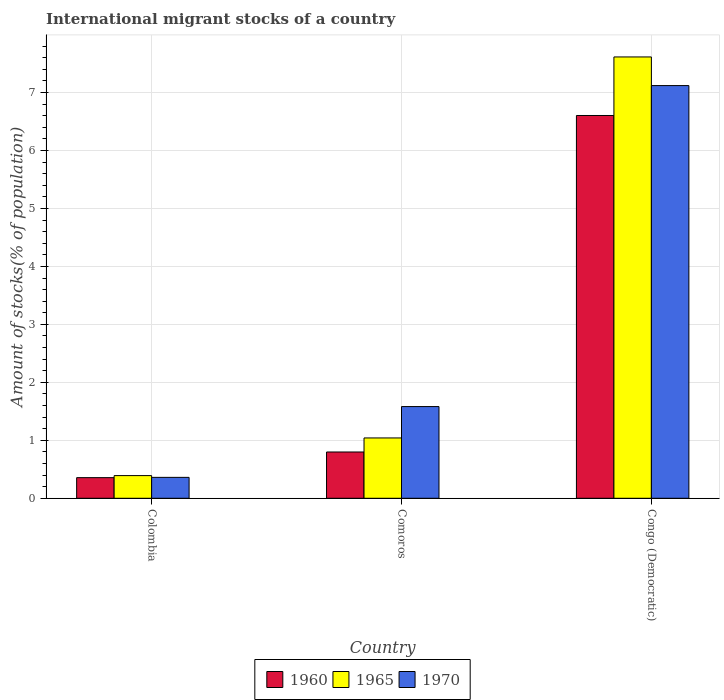Are the number of bars on each tick of the X-axis equal?
Ensure brevity in your answer.  Yes. How many bars are there on the 3rd tick from the left?
Provide a succinct answer. 3. What is the label of the 2nd group of bars from the left?
Make the answer very short. Comoros. What is the amount of stocks in in 1965 in Congo (Democratic)?
Ensure brevity in your answer.  7.61. Across all countries, what is the maximum amount of stocks in in 1965?
Your answer should be compact. 7.61. Across all countries, what is the minimum amount of stocks in in 1970?
Give a very brief answer. 0.36. In which country was the amount of stocks in in 1960 maximum?
Offer a terse response. Congo (Democratic). In which country was the amount of stocks in in 1960 minimum?
Offer a terse response. Colombia. What is the total amount of stocks in in 1970 in the graph?
Provide a succinct answer. 9.06. What is the difference between the amount of stocks in in 1960 in Colombia and that in Comoros?
Your answer should be very brief. -0.44. What is the difference between the amount of stocks in in 1965 in Colombia and the amount of stocks in in 1960 in Congo (Democratic)?
Offer a terse response. -6.21. What is the average amount of stocks in in 1960 per country?
Your answer should be very brief. 2.59. What is the difference between the amount of stocks in of/in 1965 and amount of stocks in of/in 1960 in Comoros?
Provide a short and direct response. 0.24. In how many countries, is the amount of stocks in in 1960 greater than 2.8 %?
Make the answer very short. 1. What is the ratio of the amount of stocks in in 1965 in Colombia to that in Comoros?
Offer a terse response. 0.38. Is the difference between the amount of stocks in in 1965 in Colombia and Congo (Democratic) greater than the difference between the amount of stocks in in 1960 in Colombia and Congo (Democratic)?
Ensure brevity in your answer.  No. What is the difference between the highest and the second highest amount of stocks in in 1970?
Make the answer very short. -1.22. What is the difference between the highest and the lowest amount of stocks in in 1965?
Keep it short and to the point. 7.22. Is the sum of the amount of stocks in in 1965 in Colombia and Comoros greater than the maximum amount of stocks in in 1960 across all countries?
Provide a short and direct response. No. What does the 2nd bar from the right in Colombia represents?
Offer a very short reply. 1965. How many countries are there in the graph?
Provide a succinct answer. 3. Does the graph contain any zero values?
Give a very brief answer. No. Does the graph contain grids?
Your answer should be compact. Yes. What is the title of the graph?
Ensure brevity in your answer.  International migrant stocks of a country. What is the label or title of the Y-axis?
Your response must be concise. Amount of stocks(% of population). What is the Amount of stocks(% of population) in 1960 in Colombia?
Give a very brief answer. 0.36. What is the Amount of stocks(% of population) in 1965 in Colombia?
Offer a terse response. 0.39. What is the Amount of stocks(% of population) of 1970 in Colombia?
Your answer should be very brief. 0.36. What is the Amount of stocks(% of population) in 1960 in Comoros?
Give a very brief answer. 0.8. What is the Amount of stocks(% of population) of 1965 in Comoros?
Offer a terse response. 1.04. What is the Amount of stocks(% of population) of 1970 in Comoros?
Ensure brevity in your answer.  1.58. What is the Amount of stocks(% of population) in 1960 in Congo (Democratic)?
Offer a terse response. 6.6. What is the Amount of stocks(% of population) in 1965 in Congo (Democratic)?
Your answer should be compact. 7.61. What is the Amount of stocks(% of population) in 1970 in Congo (Democratic)?
Your answer should be very brief. 7.12. Across all countries, what is the maximum Amount of stocks(% of population) of 1960?
Make the answer very short. 6.6. Across all countries, what is the maximum Amount of stocks(% of population) of 1965?
Your response must be concise. 7.61. Across all countries, what is the maximum Amount of stocks(% of population) of 1970?
Give a very brief answer. 7.12. Across all countries, what is the minimum Amount of stocks(% of population) of 1960?
Ensure brevity in your answer.  0.36. Across all countries, what is the minimum Amount of stocks(% of population) of 1965?
Your answer should be very brief. 0.39. Across all countries, what is the minimum Amount of stocks(% of population) of 1970?
Provide a succinct answer. 0.36. What is the total Amount of stocks(% of population) in 1960 in the graph?
Offer a terse response. 7.76. What is the total Amount of stocks(% of population) of 1965 in the graph?
Make the answer very short. 9.05. What is the total Amount of stocks(% of population) in 1970 in the graph?
Provide a succinct answer. 9.06. What is the difference between the Amount of stocks(% of population) of 1960 in Colombia and that in Comoros?
Ensure brevity in your answer.  -0.44. What is the difference between the Amount of stocks(% of population) of 1965 in Colombia and that in Comoros?
Offer a terse response. -0.65. What is the difference between the Amount of stocks(% of population) of 1970 in Colombia and that in Comoros?
Keep it short and to the point. -1.22. What is the difference between the Amount of stocks(% of population) of 1960 in Colombia and that in Congo (Democratic)?
Your answer should be compact. -6.25. What is the difference between the Amount of stocks(% of population) of 1965 in Colombia and that in Congo (Democratic)?
Ensure brevity in your answer.  -7.22. What is the difference between the Amount of stocks(% of population) of 1970 in Colombia and that in Congo (Democratic)?
Offer a very short reply. -6.76. What is the difference between the Amount of stocks(% of population) in 1960 in Comoros and that in Congo (Democratic)?
Make the answer very short. -5.81. What is the difference between the Amount of stocks(% of population) in 1965 in Comoros and that in Congo (Democratic)?
Keep it short and to the point. -6.57. What is the difference between the Amount of stocks(% of population) of 1970 in Comoros and that in Congo (Democratic)?
Make the answer very short. -5.54. What is the difference between the Amount of stocks(% of population) of 1960 in Colombia and the Amount of stocks(% of population) of 1965 in Comoros?
Offer a terse response. -0.68. What is the difference between the Amount of stocks(% of population) of 1960 in Colombia and the Amount of stocks(% of population) of 1970 in Comoros?
Offer a terse response. -1.23. What is the difference between the Amount of stocks(% of population) of 1965 in Colombia and the Amount of stocks(% of population) of 1970 in Comoros?
Provide a succinct answer. -1.19. What is the difference between the Amount of stocks(% of population) in 1960 in Colombia and the Amount of stocks(% of population) in 1965 in Congo (Democratic)?
Keep it short and to the point. -7.26. What is the difference between the Amount of stocks(% of population) in 1960 in Colombia and the Amount of stocks(% of population) in 1970 in Congo (Democratic)?
Your answer should be compact. -6.76. What is the difference between the Amount of stocks(% of population) in 1965 in Colombia and the Amount of stocks(% of population) in 1970 in Congo (Democratic)?
Ensure brevity in your answer.  -6.73. What is the difference between the Amount of stocks(% of population) of 1960 in Comoros and the Amount of stocks(% of population) of 1965 in Congo (Democratic)?
Provide a short and direct response. -6.82. What is the difference between the Amount of stocks(% of population) of 1960 in Comoros and the Amount of stocks(% of population) of 1970 in Congo (Democratic)?
Offer a terse response. -6.32. What is the difference between the Amount of stocks(% of population) in 1965 in Comoros and the Amount of stocks(% of population) in 1970 in Congo (Democratic)?
Your answer should be compact. -6.08. What is the average Amount of stocks(% of population) of 1960 per country?
Your answer should be very brief. 2.59. What is the average Amount of stocks(% of population) in 1965 per country?
Give a very brief answer. 3.02. What is the average Amount of stocks(% of population) in 1970 per country?
Offer a terse response. 3.02. What is the difference between the Amount of stocks(% of population) in 1960 and Amount of stocks(% of population) in 1965 in Colombia?
Provide a short and direct response. -0.04. What is the difference between the Amount of stocks(% of population) of 1960 and Amount of stocks(% of population) of 1970 in Colombia?
Keep it short and to the point. -0. What is the difference between the Amount of stocks(% of population) in 1965 and Amount of stocks(% of population) in 1970 in Colombia?
Offer a very short reply. 0.03. What is the difference between the Amount of stocks(% of population) in 1960 and Amount of stocks(% of population) in 1965 in Comoros?
Offer a terse response. -0.24. What is the difference between the Amount of stocks(% of population) of 1960 and Amount of stocks(% of population) of 1970 in Comoros?
Your response must be concise. -0.78. What is the difference between the Amount of stocks(% of population) of 1965 and Amount of stocks(% of population) of 1970 in Comoros?
Offer a very short reply. -0.54. What is the difference between the Amount of stocks(% of population) in 1960 and Amount of stocks(% of population) in 1965 in Congo (Democratic)?
Offer a terse response. -1.01. What is the difference between the Amount of stocks(% of population) of 1960 and Amount of stocks(% of population) of 1970 in Congo (Democratic)?
Make the answer very short. -0.52. What is the difference between the Amount of stocks(% of population) in 1965 and Amount of stocks(% of population) in 1970 in Congo (Democratic)?
Keep it short and to the point. 0.49. What is the ratio of the Amount of stocks(% of population) in 1960 in Colombia to that in Comoros?
Offer a terse response. 0.45. What is the ratio of the Amount of stocks(% of population) of 1965 in Colombia to that in Comoros?
Keep it short and to the point. 0.38. What is the ratio of the Amount of stocks(% of population) in 1970 in Colombia to that in Comoros?
Your answer should be compact. 0.23. What is the ratio of the Amount of stocks(% of population) in 1960 in Colombia to that in Congo (Democratic)?
Offer a terse response. 0.05. What is the ratio of the Amount of stocks(% of population) in 1965 in Colombia to that in Congo (Democratic)?
Give a very brief answer. 0.05. What is the ratio of the Amount of stocks(% of population) of 1970 in Colombia to that in Congo (Democratic)?
Provide a short and direct response. 0.05. What is the ratio of the Amount of stocks(% of population) in 1960 in Comoros to that in Congo (Democratic)?
Your response must be concise. 0.12. What is the ratio of the Amount of stocks(% of population) in 1965 in Comoros to that in Congo (Democratic)?
Give a very brief answer. 0.14. What is the ratio of the Amount of stocks(% of population) of 1970 in Comoros to that in Congo (Democratic)?
Keep it short and to the point. 0.22. What is the difference between the highest and the second highest Amount of stocks(% of population) in 1960?
Your response must be concise. 5.81. What is the difference between the highest and the second highest Amount of stocks(% of population) of 1965?
Your answer should be very brief. 6.57. What is the difference between the highest and the second highest Amount of stocks(% of population) in 1970?
Your answer should be compact. 5.54. What is the difference between the highest and the lowest Amount of stocks(% of population) of 1960?
Provide a succinct answer. 6.25. What is the difference between the highest and the lowest Amount of stocks(% of population) in 1965?
Offer a terse response. 7.22. What is the difference between the highest and the lowest Amount of stocks(% of population) of 1970?
Provide a short and direct response. 6.76. 